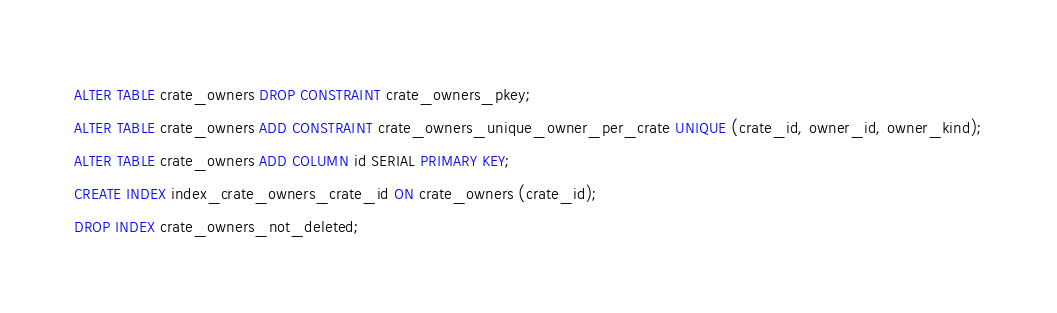Convert code to text. <code><loc_0><loc_0><loc_500><loc_500><_SQL_>ALTER TABLE crate_owners DROP CONSTRAINT crate_owners_pkey;
ALTER TABLE crate_owners ADD CONSTRAINT crate_owners_unique_owner_per_crate UNIQUE (crate_id, owner_id, owner_kind);
ALTER TABLE crate_owners ADD COLUMN id SERIAL PRIMARY KEY;
CREATE INDEX index_crate_owners_crate_id ON crate_owners (crate_id);
DROP INDEX crate_owners_not_deleted;
</code> 